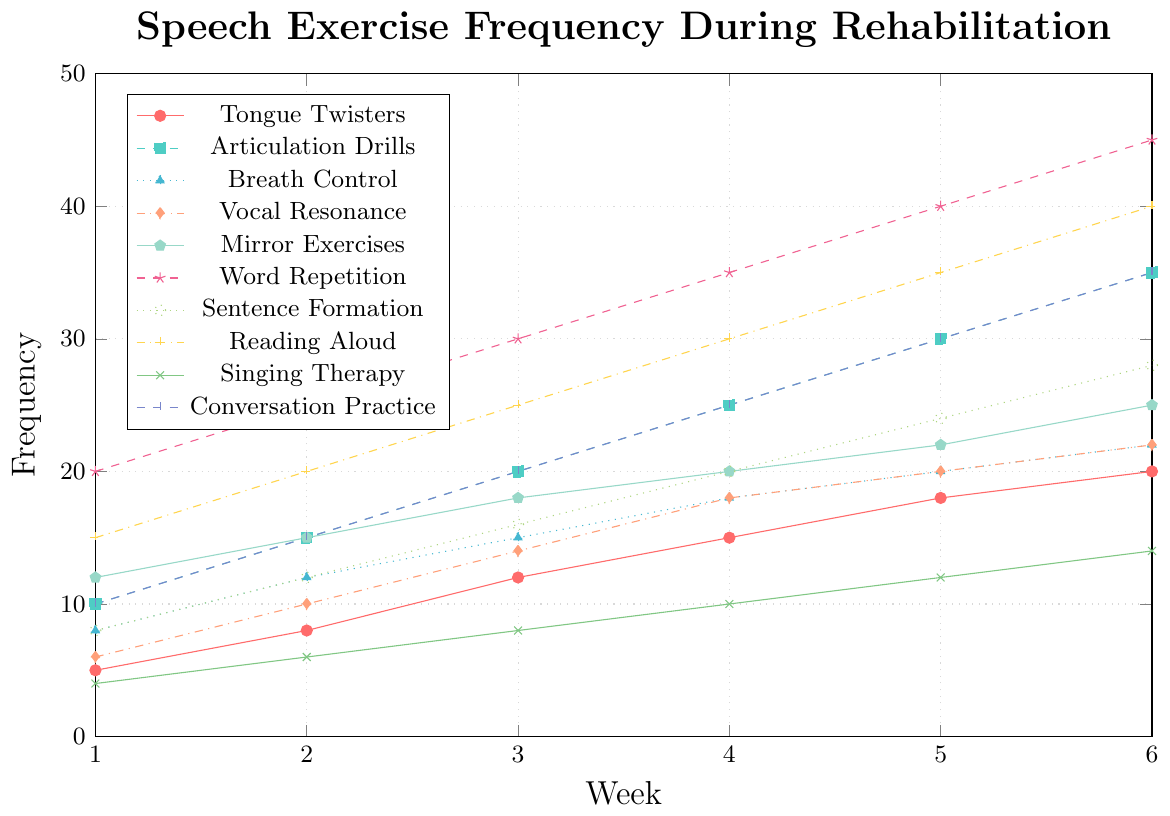What's the frequency of Word Repetition in Week 3? Look at the legend to find Word Repetition, then find the corresponding line on the graph. Locate Week 3 on the x-axis and see where the Word Repetition line intersects.
Answer: 30 Which exercise has the highest frequency in Week 6? Check all the values at Week 6 on the x-axis and find the highest point on the y-axis.
Answer: Word Repetition By how much did Conversation Practice increase from Week 1 to Week 6? Locate the values for Conversation Practice at Week 1 and Week 6. Subtract the Week 1 value from the Week 6 value: 35 - 10.
Answer: 25 What is the average frequency of Breath Control Exercises over the 6 weeks? Sum up the frequencies of Breath Control Exercises: 8 + 12 + 15 + 18 + 20 + 22 = 95. Divide by the number of weeks: 95 ÷ 6.
Answer: ~15.83 Which exercise showed no change in frequency from Week 4 to Week 5? Identify the lines on the graph that remain flat between Week 4 and Week 5.
Answer: Vocal Resonance Practice, Breath Control Exercises Rank the exercises in Week 2 by their frequency, from highest to lowest. Locate the values for Week 2 on the x-axis and list them in descending order.
Answer: Word Repetition, Reading Aloud, Conversation Practice, Articulation Drills, Mirror Exercises, Sentence Formation, Breath Control Exercises, Vocal Resonance Practice, Tongue Twisters, Singing Therapy Which two exercises have the same frequency in Week 6? Compare the y-values for all exercises at Week 6 and find pairs of lines that intersect at the same point.
Answer: Breath Control Exercises and Vocal Resonance Practice What is the total frequency of Mirror Exercises over the 6 weeks? Sum the frequencies for Mirror Exercises over all 6 weeks: 12 + 15 + 18 + 20 + 22 + 25.
Answer: 112 What's the difference in frequency between Articulation Drills and Singing Therapy in Week 5? Find the frequencies of Articulation Drills and Singing Therapy in Week 5, then subtract the smaller from the larger: 30 - 12.
Answer: 18 Which exercise increased the most from Week 1 to Week 2? Calculate the increase for each exercise from Week 1 to Week 2 and identify the highest increase.
Answer: Word Repetition 